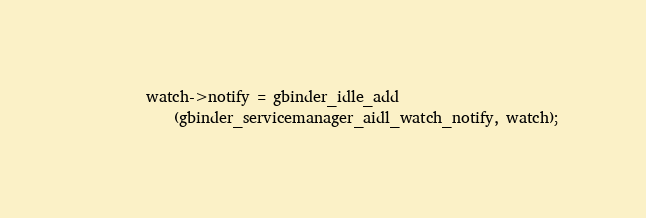Convert code to text. <code><loc_0><loc_0><loc_500><loc_500><_C_>        watch->notify = gbinder_idle_add
            (gbinder_servicemanager_aidl_watch_notify, watch);</code> 